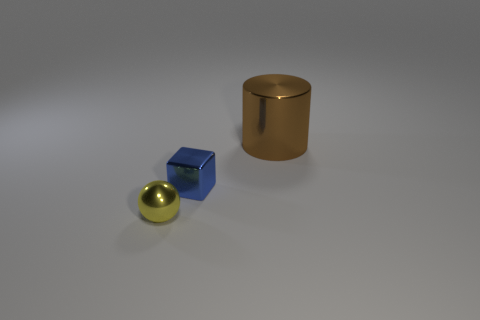There is a thing on the left side of the small metal object that is on the right side of the yellow thing; what color is it?
Keep it short and to the point. Yellow. Is the shape of the large brown metallic thing the same as the tiny metallic object to the left of the blue thing?
Make the answer very short. No. The small thing that is behind the thing that is in front of the tiny shiny object behind the yellow shiny ball is made of what material?
Your response must be concise. Metal. Is there a cylinder that has the same size as the shiny cube?
Offer a very short reply. No. What size is the brown cylinder that is the same material as the small yellow object?
Provide a short and direct response. Large. The big brown object is what shape?
Make the answer very short. Cylinder. Is the material of the block the same as the small object in front of the block?
Keep it short and to the point. Yes. How many objects are either metal spheres or tiny blocks?
Make the answer very short. 2. Are there any large green rubber things?
Give a very brief answer. No. What shape is the small object that is behind the thing in front of the blue thing?
Your answer should be very brief. Cube. 